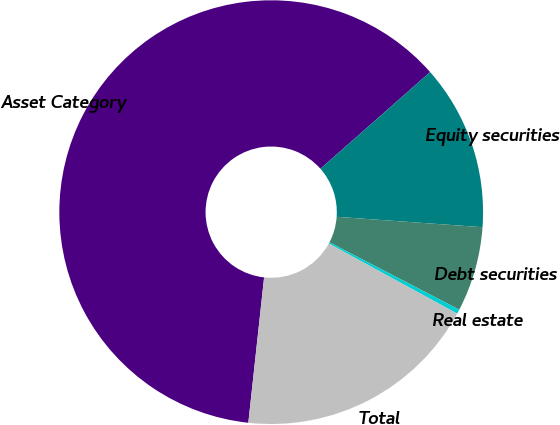Convert chart. <chart><loc_0><loc_0><loc_500><loc_500><pie_chart><fcel>Asset Category<fcel>Equity securities<fcel>Debt securities<fcel>Real estate<fcel>Total<nl><fcel>61.78%<fcel>12.63%<fcel>6.48%<fcel>0.34%<fcel>18.77%<nl></chart> 